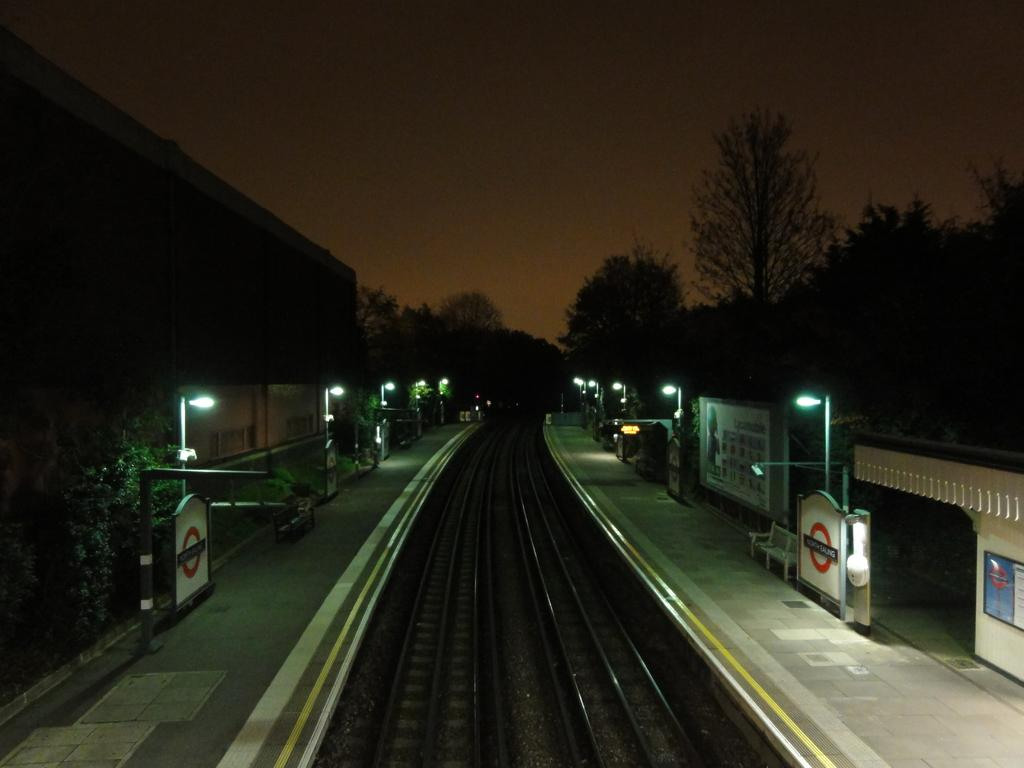What is in the foreground of the image? There is a railway track in the foreground of the image. What is located on either side of the railway track? There is a platform on either side of the railway track. What can be seen in the image that provides illumination? Lights are present in the image. What structures are visible in the image that support the lights? Poles are visible in the image. What type of vegetation is present in the image? Trees are present in the image. What type of man-made structures are visible in the image? Buildings are visible in the image. What is visible in the background of the image? There are trees and a dark sky in the background of the image. Where is the shop located in the image? There is no shop present in the image. What type of note is being passed between the trees in the background? There are no notes or any indication of communication between the trees in the image. 